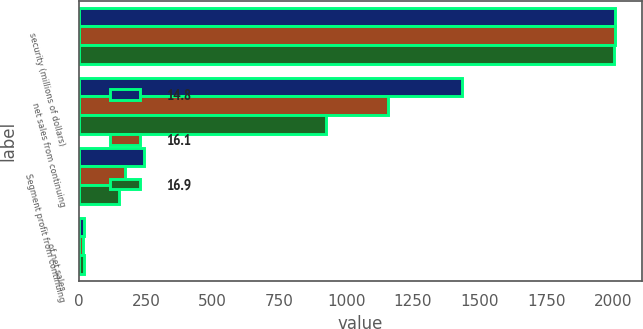Convert chart. <chart><loc_0><loc_0><loc_500><loc_500><stacked_bar_chart><ecel><fcel>security (millions of dollars)<fcel>net sales from continuing<fcel>Segment profit from continuing<fcel>of net sales<nl><fcel>14.8<fcel>2007<fcel>1433<fcel>242<fcel>16.9<nl><fcel>16.1<fcel>2006<fcel>1157<fcel>172<fcel>14.8<nl><fcel>16.9<fcel>2005<fcel>924<fcel>149<fcel>16.1<nl></chart> 